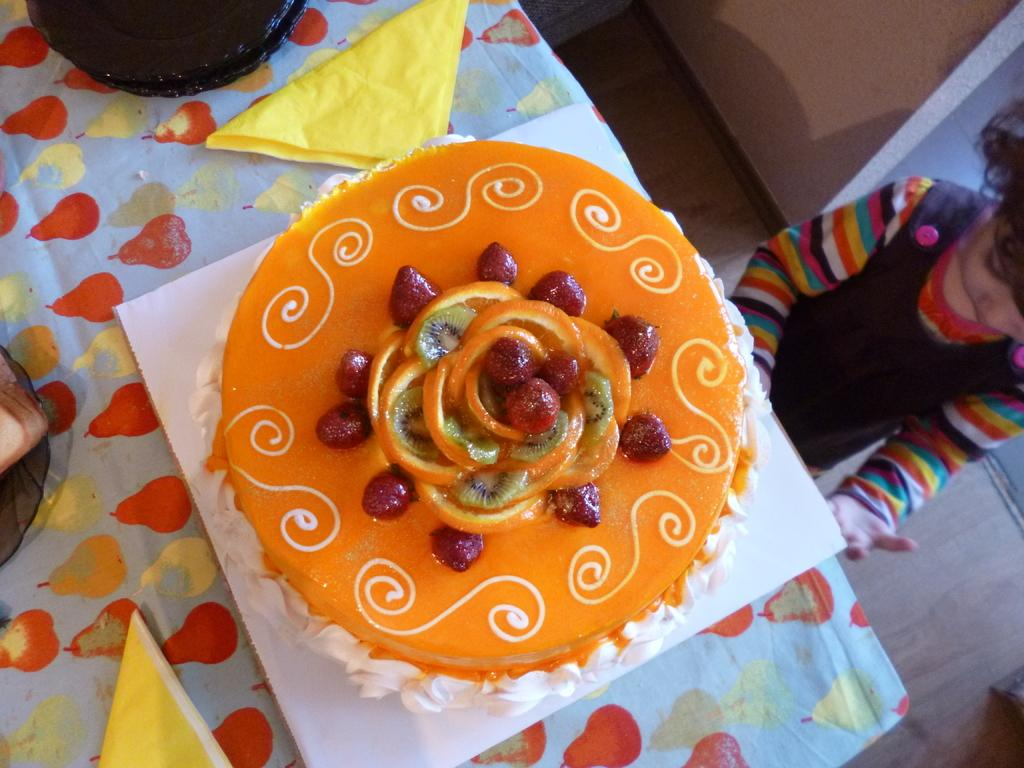What is the main object on the table in the image? There is a cake placed on a table in the image. Where is the cake located in relation to the other elements in the image? The cake is placed on a table in the image. What can be seen in the background of the image? There is a wall visible in the image. Can you describe the person in the image? There is a girl in the image. What type of transport is used by the girl in the image? There is no transport visible in the image, as it only features a cake, table, wall, and a girl. What is the purpose of the pump in the image? There is no pump present in the image. 